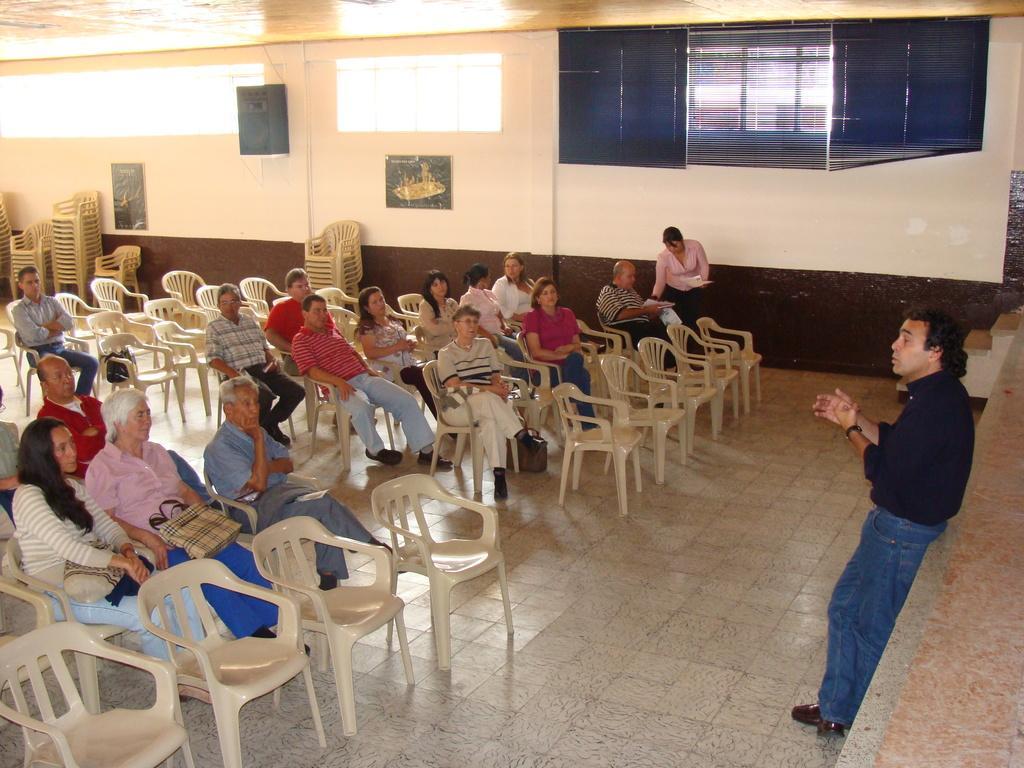Can you describe this image briefly? This is a picture taken in a hall, there are a group of people sitting on chairs in front of these people there is a man in black shirt was standing on the floor and explaining something. Behind these people there is a wall. 